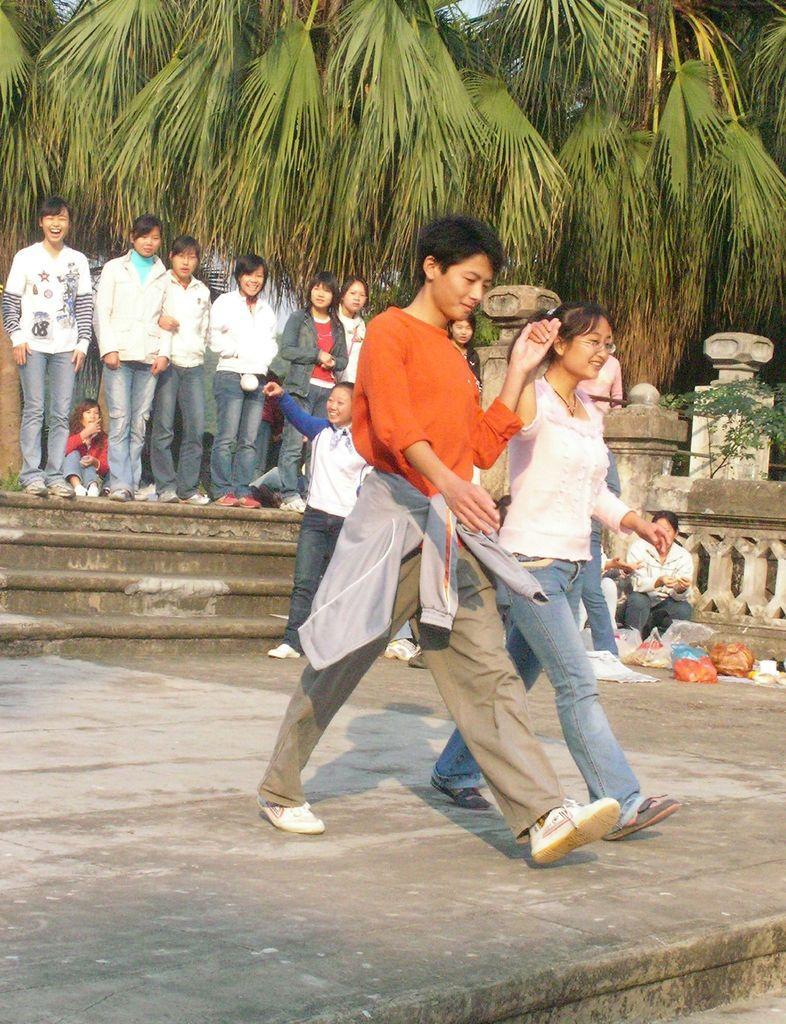Describe this image in one or two sentences. In this image there are a few people walking, behind them there are a few people standing with a smile on their face, few are sitting in front of them there are few bags, there are stairs and a wall. In the background there are trees. 